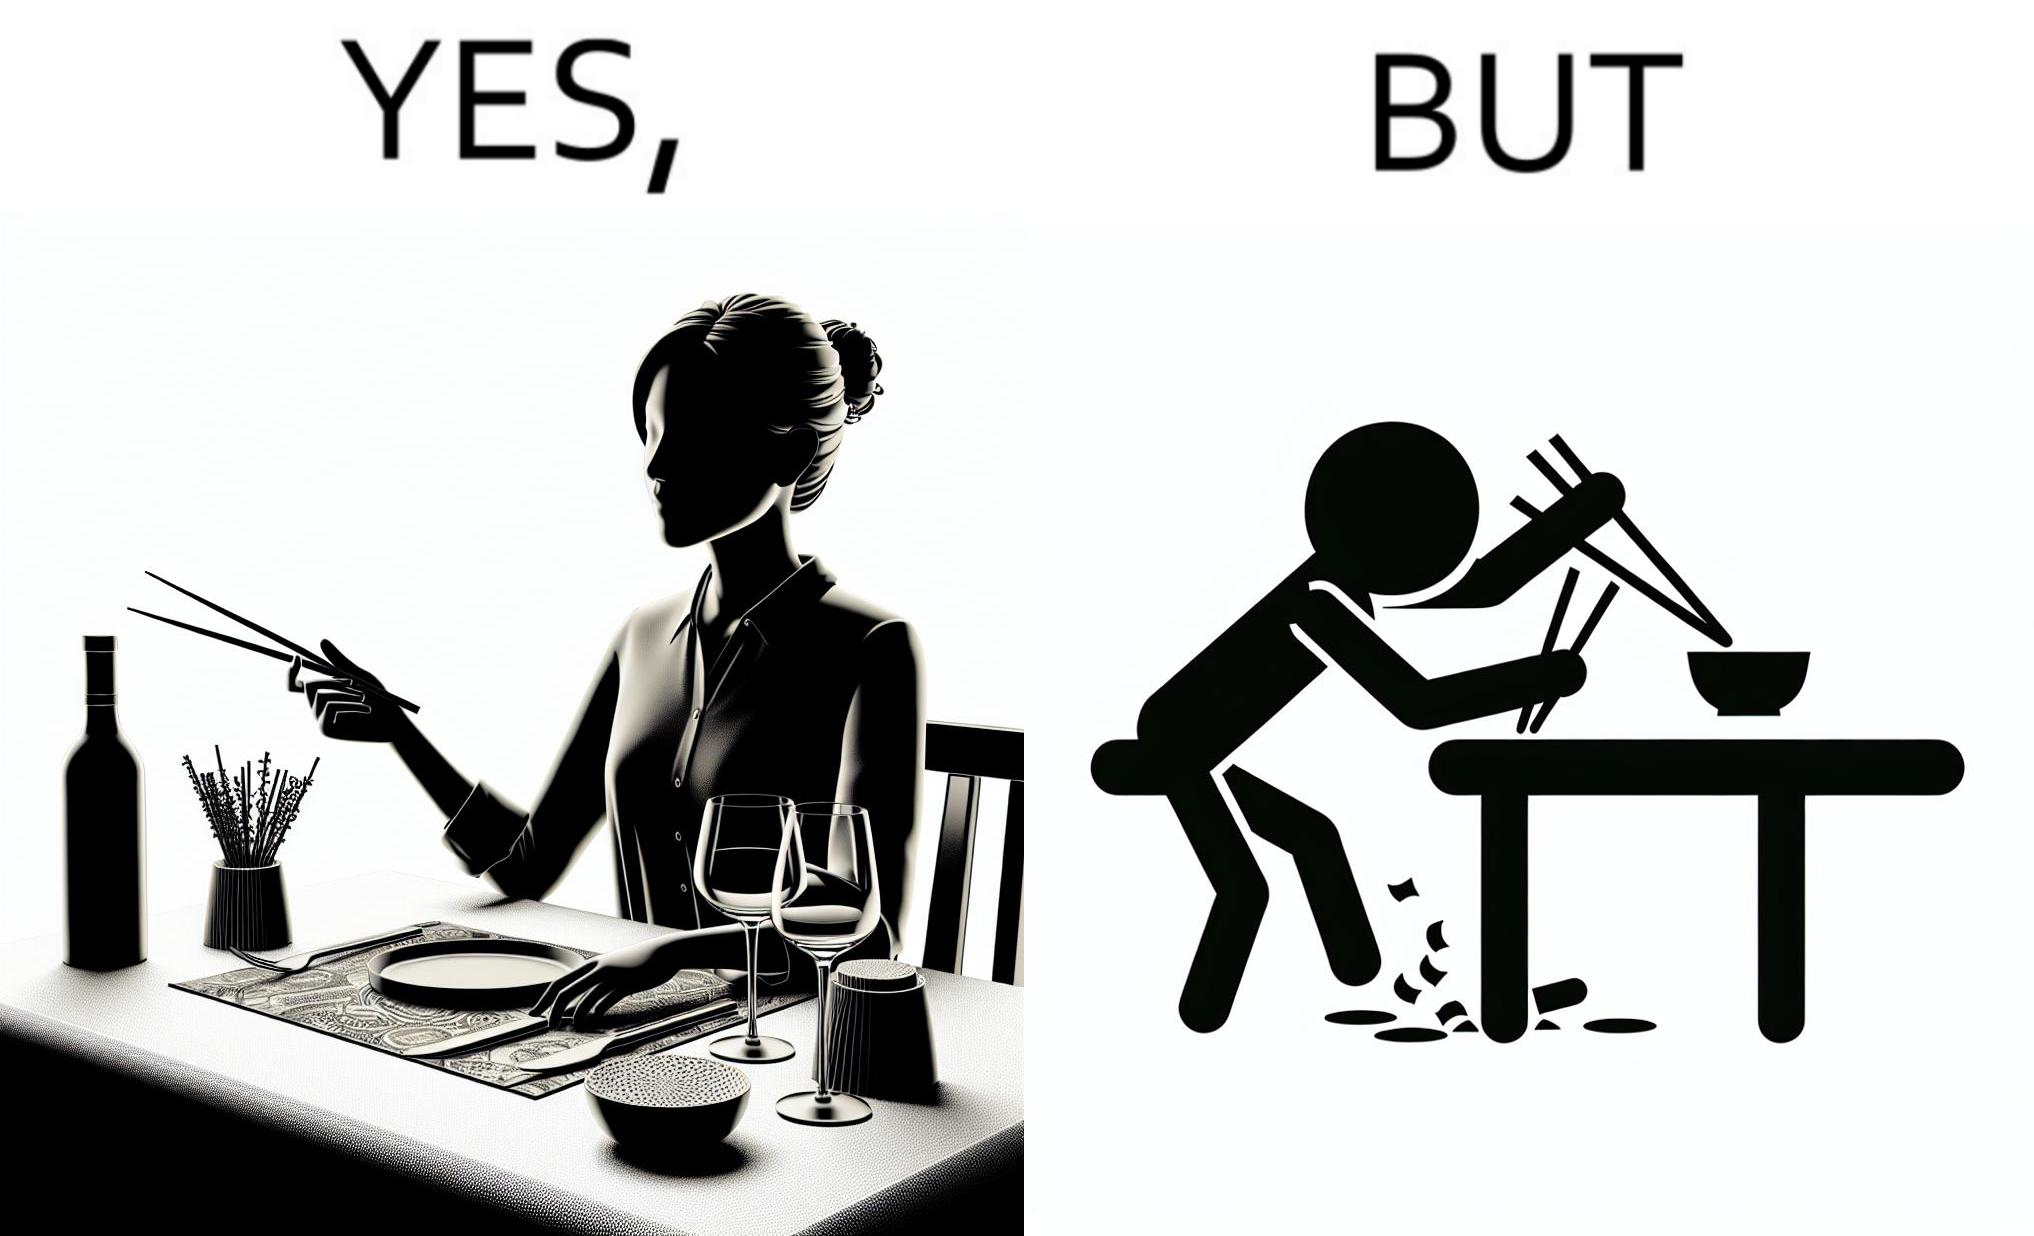What is shown in the left half versus the right half of this image? In the left part of the image: The image shows a woman sitting at a table in a restaruant pointing to chopsticks on her table. There is also a wine glass, a fork and a knief on her table. In the right part of the image: The image shows a person using chopstick to pick up food from the cup. The person is not able to handle food with chopstick well and is dropping the food around the cup on the table. 